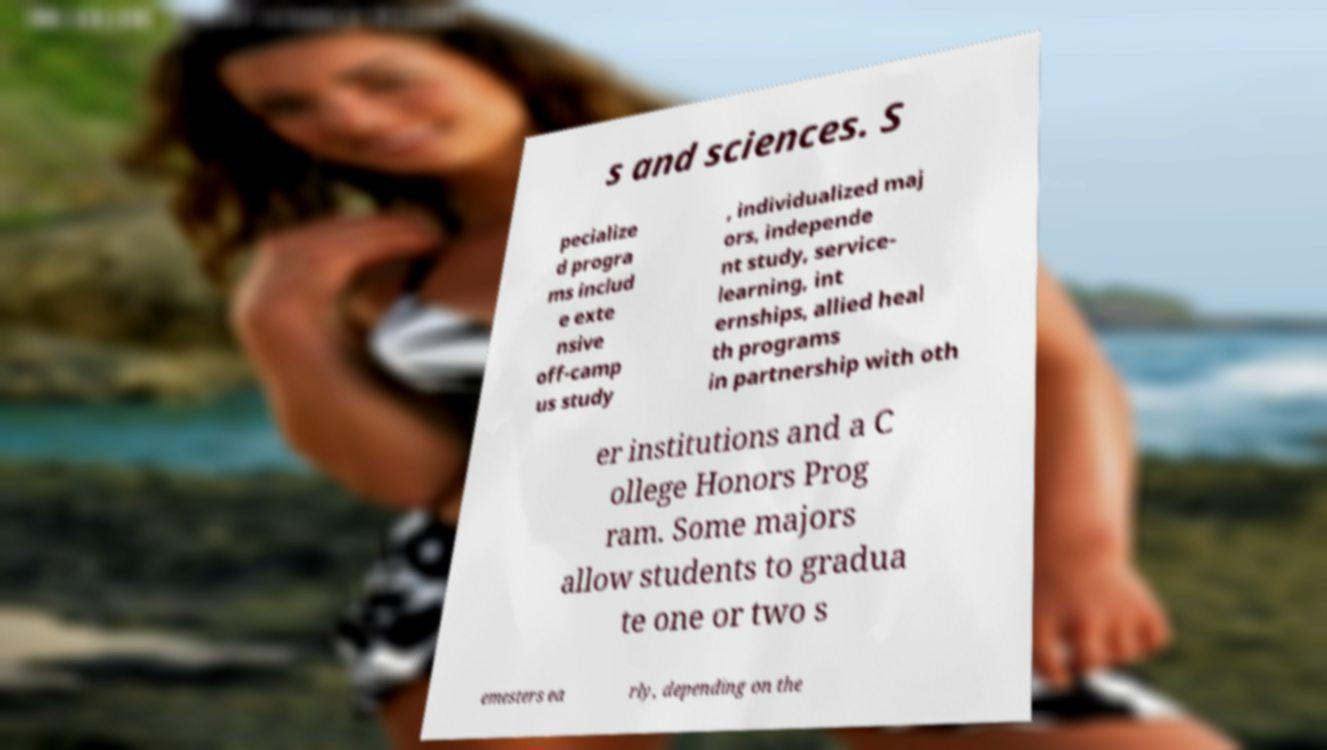Can you read and provide the text displayed in the image?This photo seems to have some interesting text. Can you extract and type it out for me? s and sciences. S pecialize d progra ms includ e exte nsive off-camp us study , individualized maj ors, independe nt study, service- learning, int ernships, allied heal th programs in partnership with oth er institutions and a C ollege Honors Prog ram. Some majors allow students to gradua te one or two s emesters ea rly, depending on the 